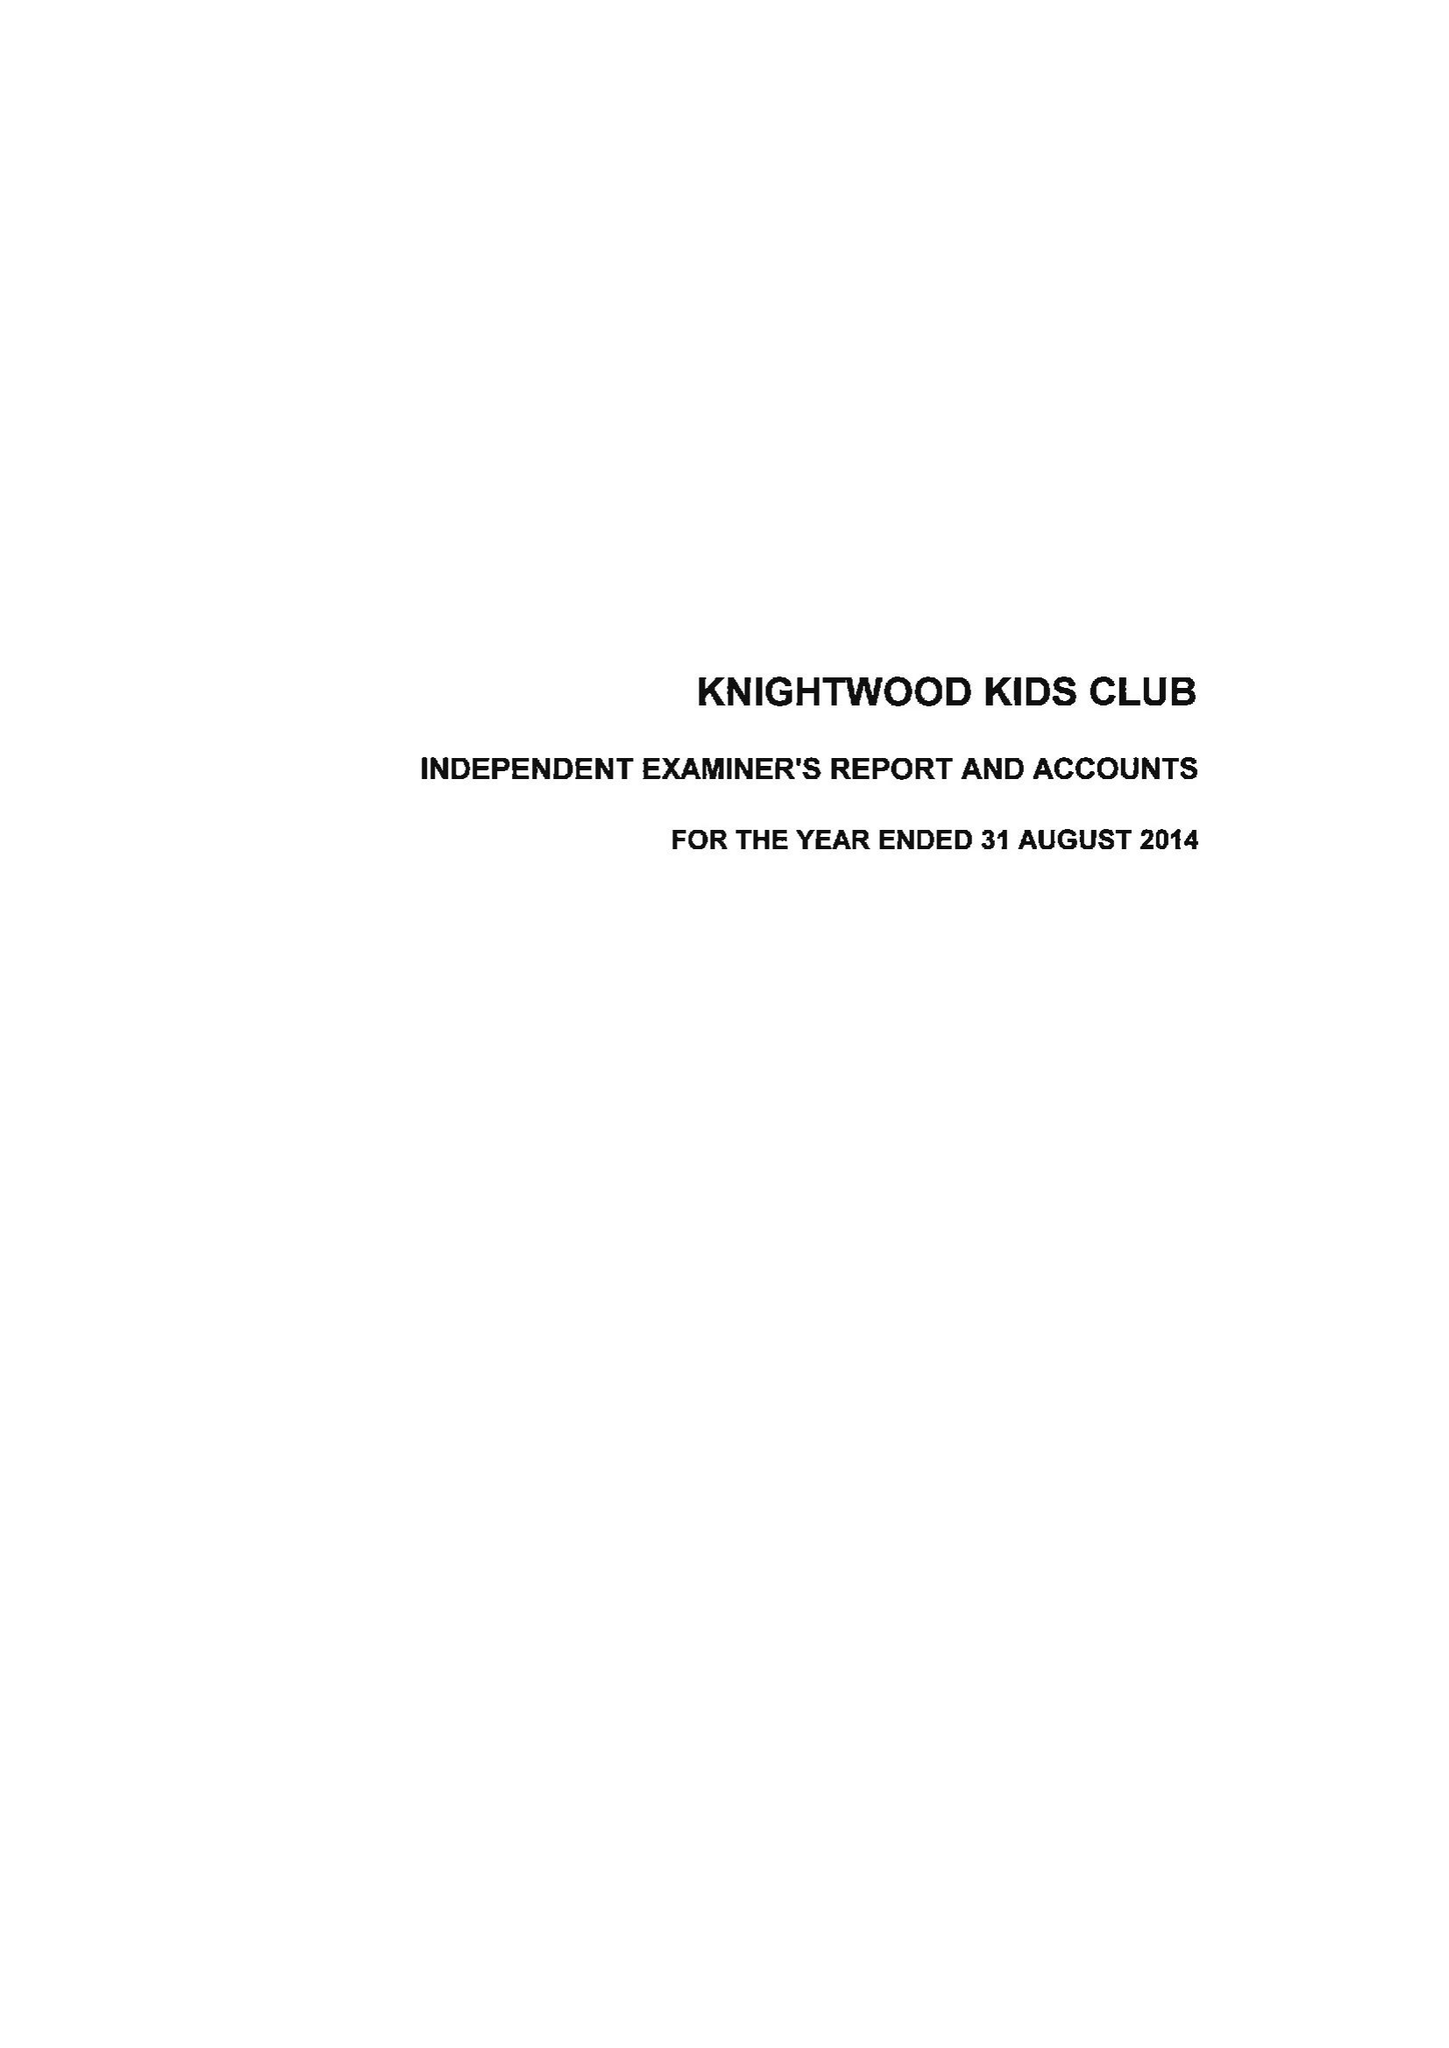What is the value for the address__street_line?
Answer the question using a single word or phrase. None 